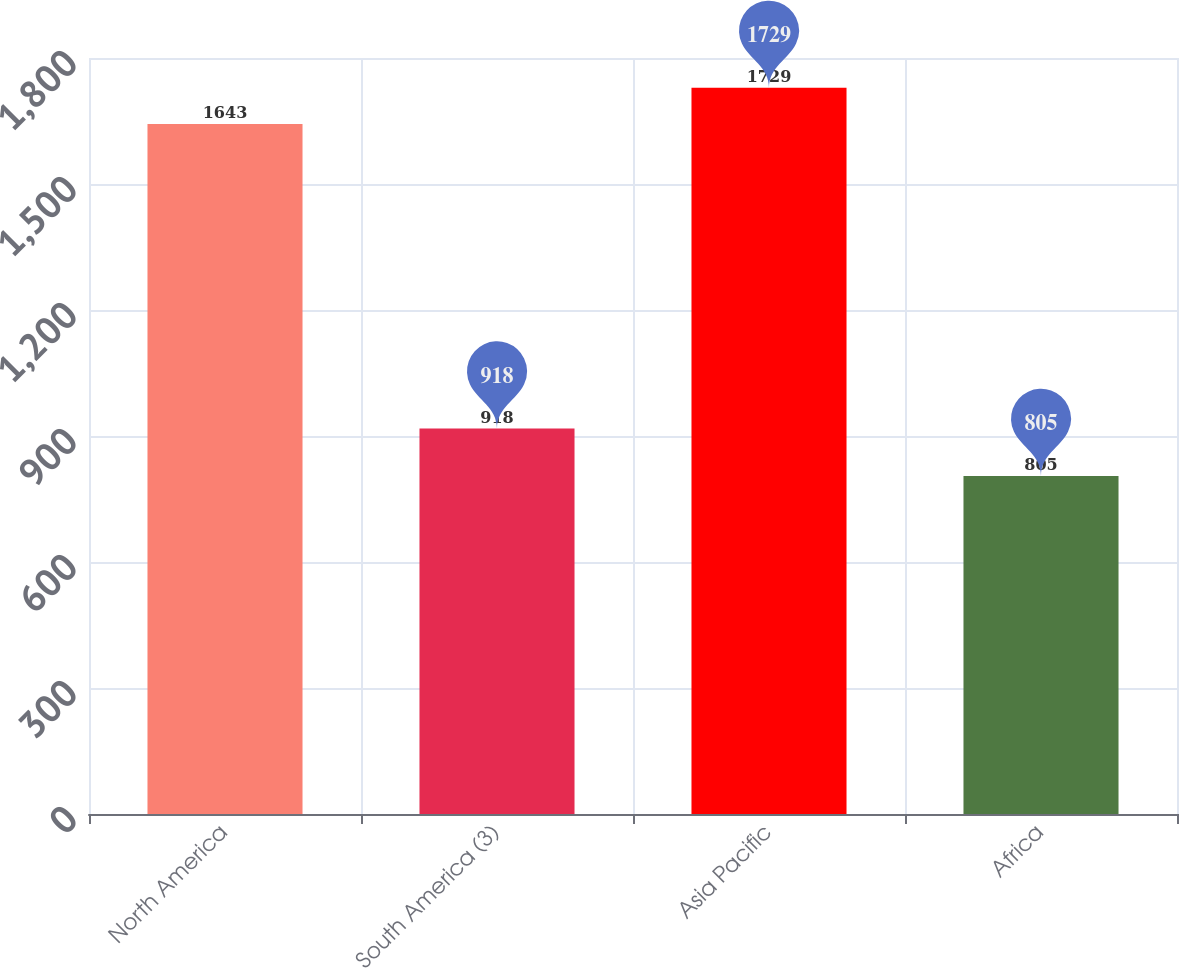Convert chart. <chart><loc_0><loc_0><loc_500><loc_500><bar_chart><fcel>North America<fcel>South America (3)<fcel>Asia Pacific<fcel>Africa<nl><fcel>1643<fcel>918<fcel>1729<fcel>805<nl></chart> 